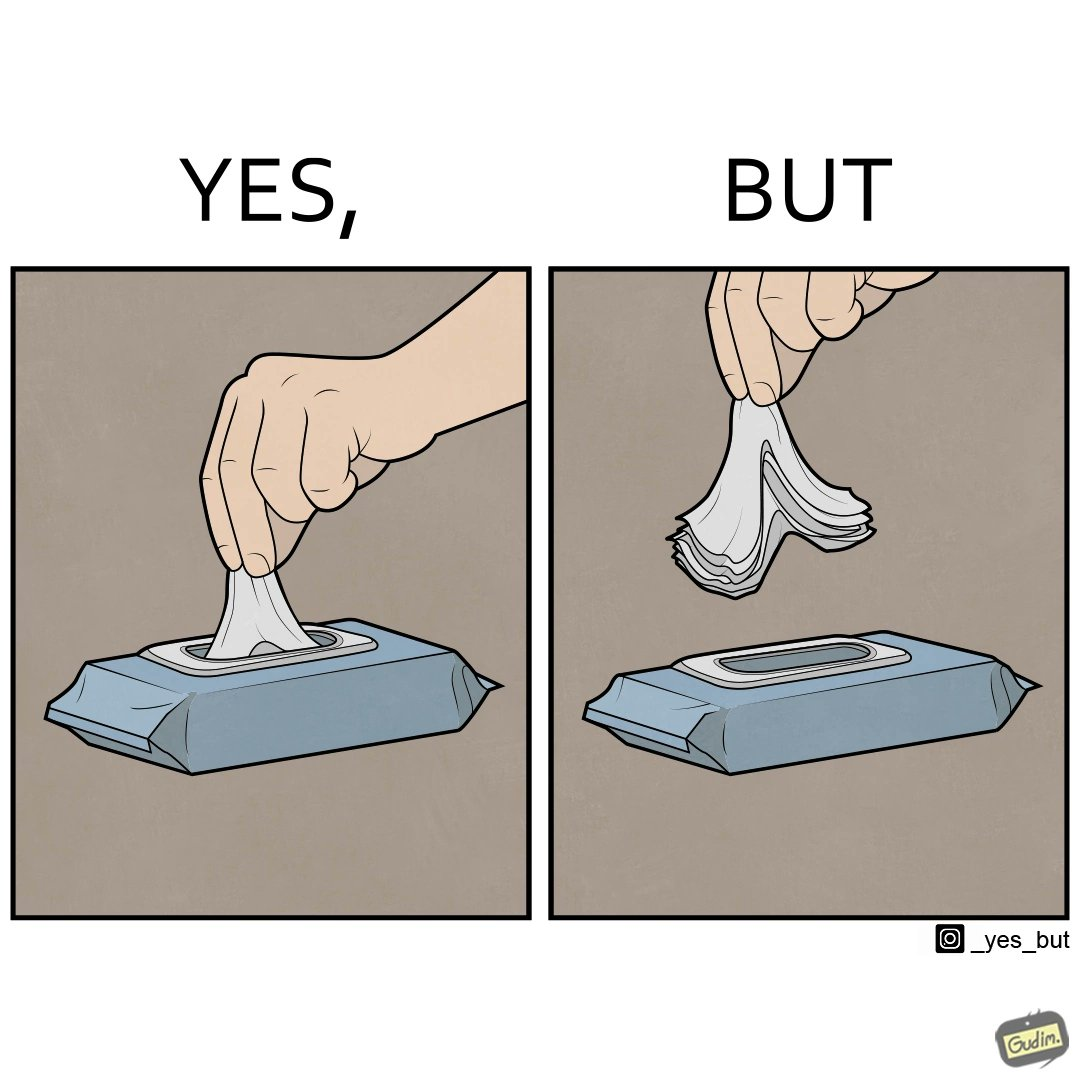Why is this image considered satirical? The image is ironic, because even when there is a need of only one napkin but the napkins are so tightly packed that more than one napkin gets out sticked together 